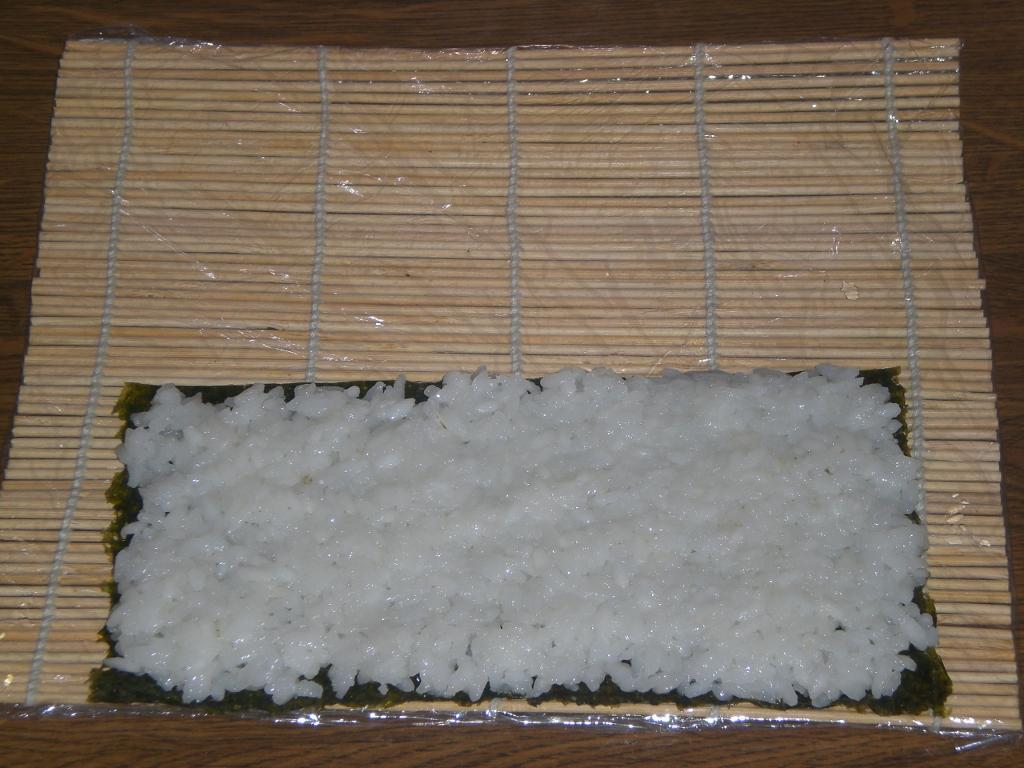Describe this image in one or two sentences. In this image, we can see cooked rice on the cloth and there is a wooden sticks mat are on the table. 